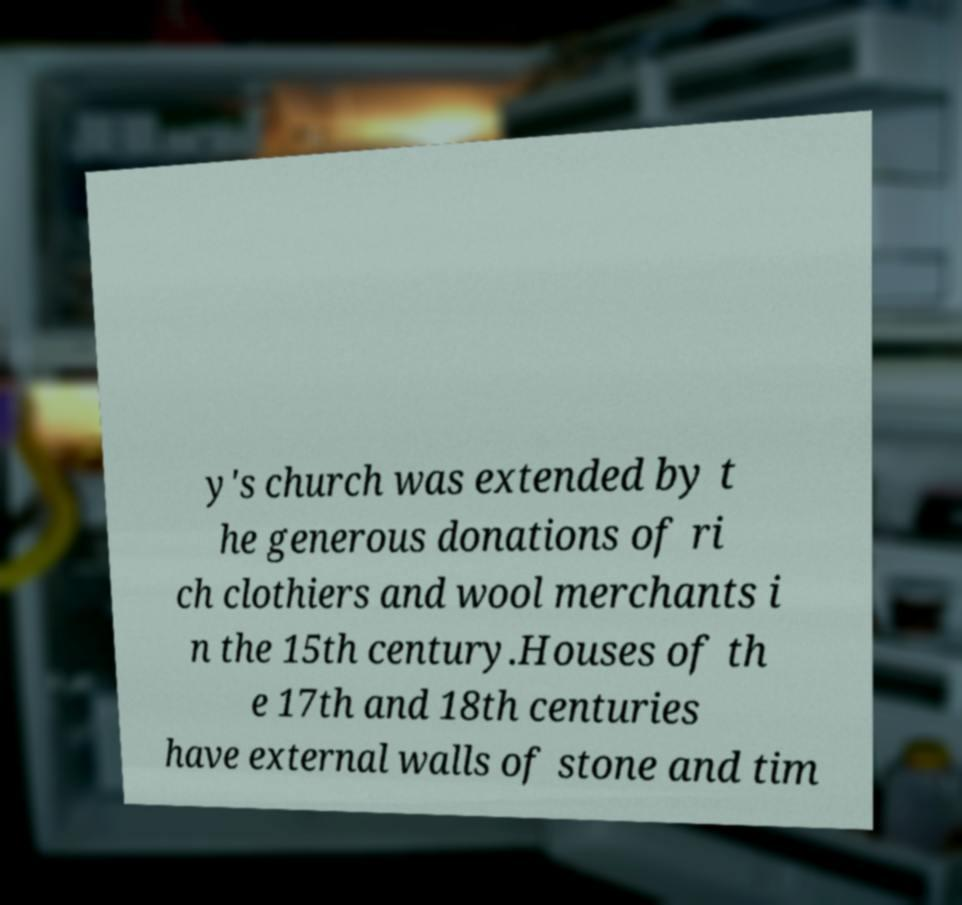What messages or text are displayed in this image? I need them in a readable, typed format. y's church was extended by t he generous donations of ri ch clothiers and wool merchants i n the 15th century.Houses of th e 17th and 18th centuries have external walls of stone and tim 